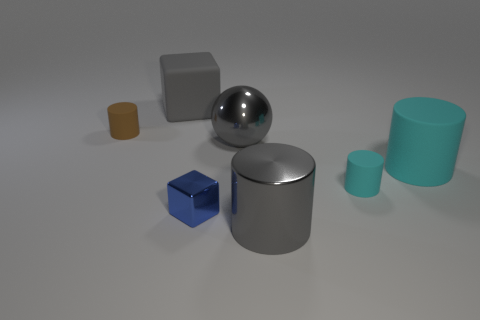Add 1 large yellow metallic spheres. How many objects exist? 8 Subtract all spheres. How many objects are left? 6 Add 2 metal spheres. How many metal spheres exist? 3 Subtract 0 brown balls. How many objects are left? 7 Subtract all small brown matte objects. Subtract all blue shiny things. How many objects are left? 5 Add 3 big gray rubber cubes. How many big gray rubber cubes are left? 4 